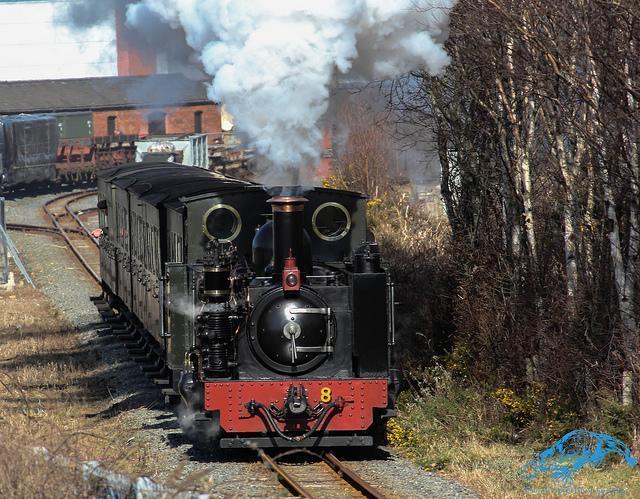How many trains are there?
Give a very brief answer. 2. 